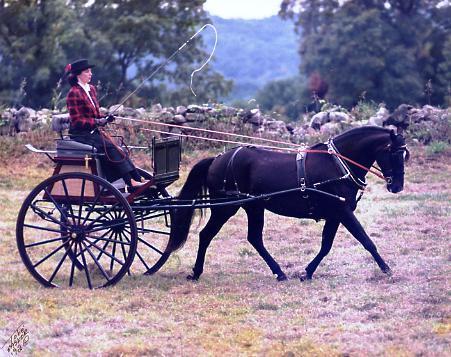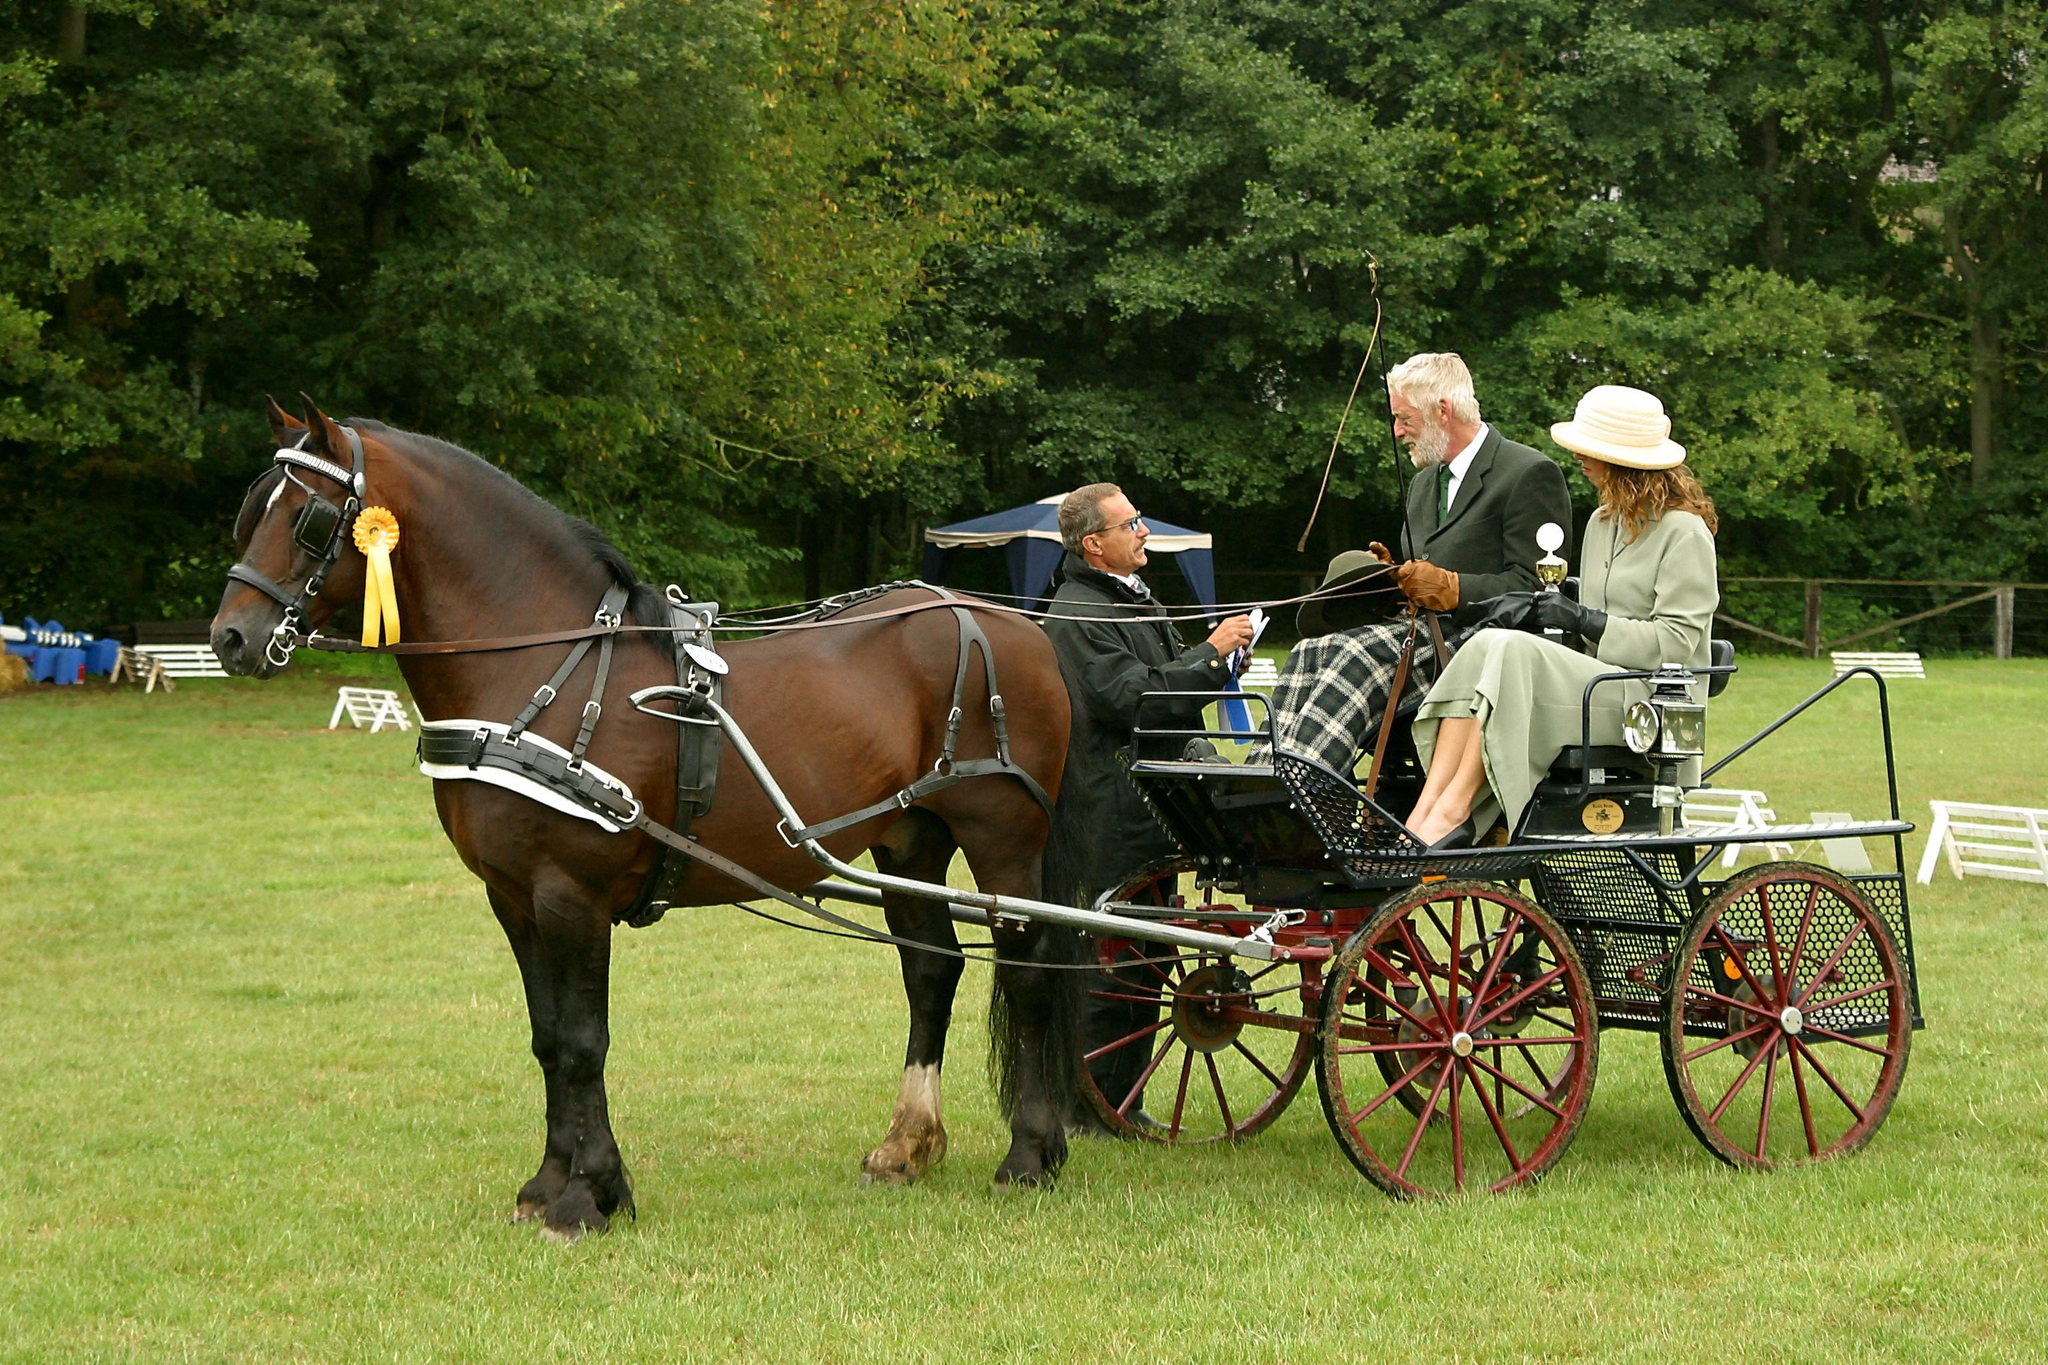The first image is the image on the left, the second image is the image on the right. For the images shown, is this caption "There is one human being pulled by a horse facing right." true? Answer yes or no. Yes. The first image is the image on the left, the second image is the image on the right. Considering the images on both sides, is "There are two humans riding a horse carriage in one of the images." valid? Answer yes or no. Yes. 